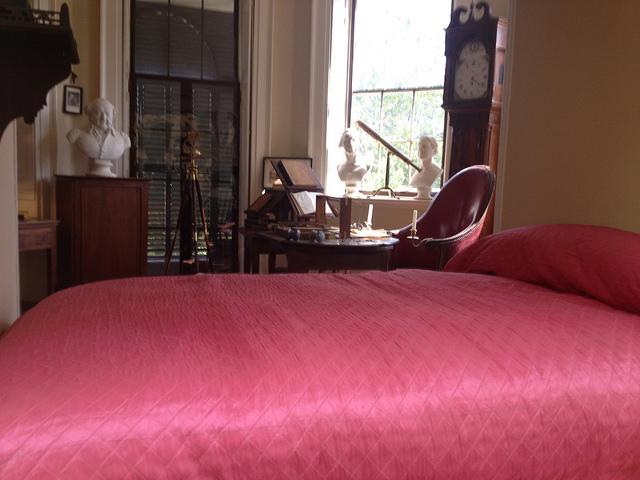What's on top of the cupboard?
Concise answer only. Statue. What type of clock is in the room?
Short answer required. Grandfather. What is the color of the sheets?
Keep it brief. Red. 